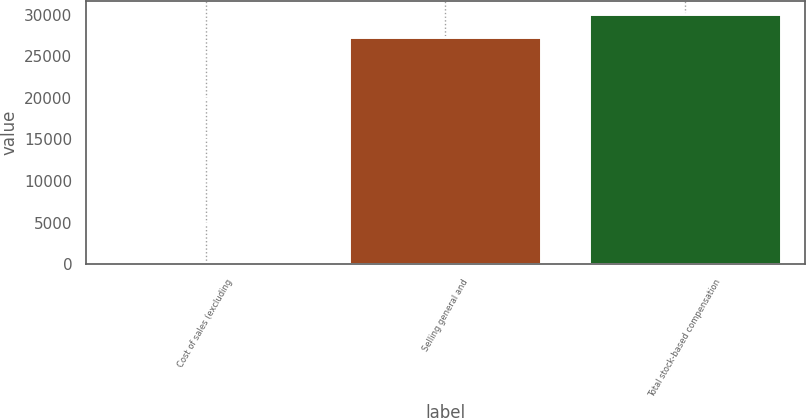<chart> <loc_0><loc_0><loc_500><loc_500><bar_chart><fcel>Cost of sales (excluding<fcel>Selling general and<fcel>Total stock-based compensation<nl><fcel>220<fcel>27365<fcel>30101.5<nl></chart> 